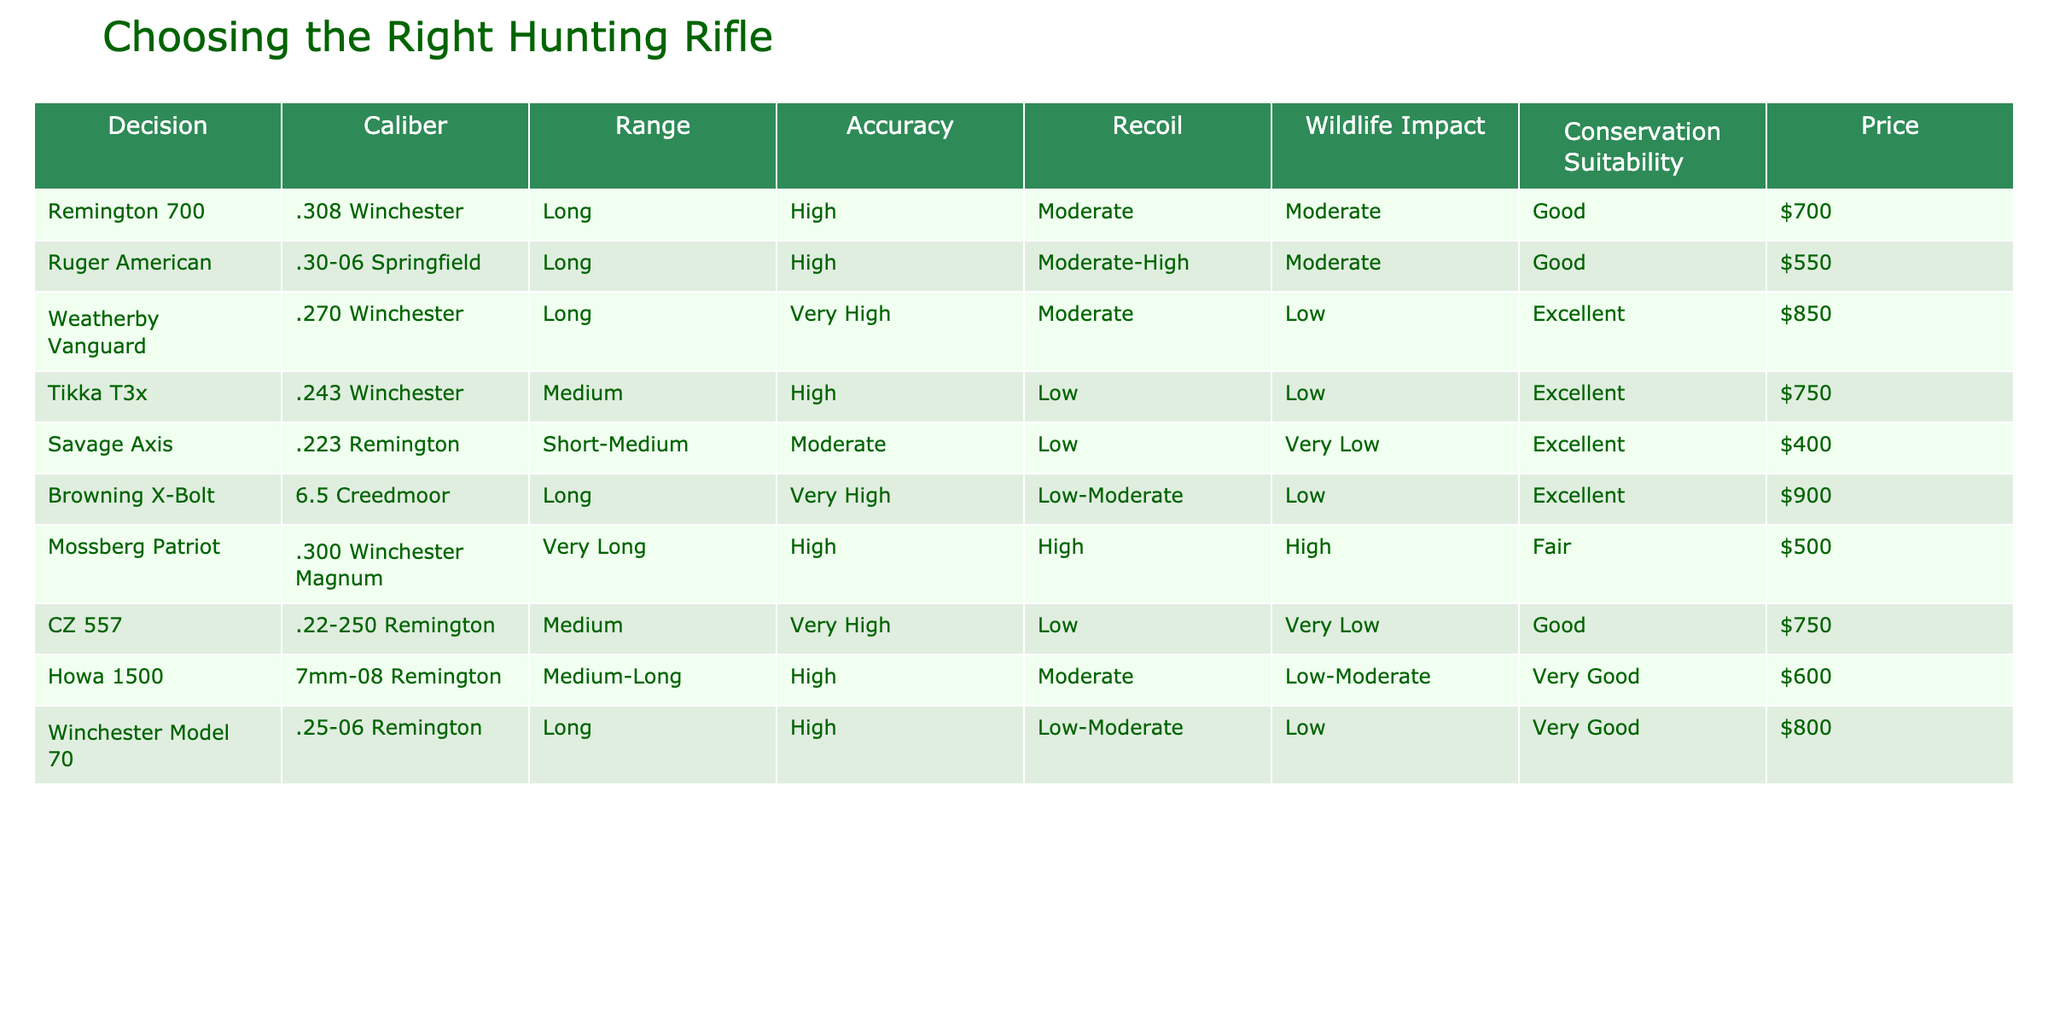What is the caliber of the rifle with the highest accuracy? The table shows that the rifle with the highest accuracy is the Weatherby Vanguard, which uses the .270 Winchester caliber.
Answer: .270 Winchester Which rifle has the lowest price while still being classified as excellent in conservation suitability? The Savage Axis is priced at $400 and is classified as excellent in conservation suitability.
Answer: $400 What is the average accuracy rating of rifles classified as excellent for conservation suitability? The rifles classified as excellent for conservation suitability are the Weatherby Vanguard, Tikka T3x, Savage Axis, Browning X-Bolt, and Howa 1500. Their accuracy ratings are Very High, High, Moderate, Very High, and High, respectively. To quantify these: Very High = 4, High = 3, Moderate = 2. The sum is 4 + 3 + 2 + 4 + 3 = 16 and there are 5 rifles, so the average is 16 / 5 = 3.2.
Answer: 3.2 Does any rifle have a very high accuracy and very low wildlife impact? The Tikka T3x has very high accuracy and very low wildlife impact, as reflected in the table.
Answer: Yes Which rifle has the highest recoil and what is its caliber? The rifle with the highest recoil is the Mossberg Patriot, which has a caliber of .300 Winchester Magnum.
Answer: .300 Winchester Magnum 